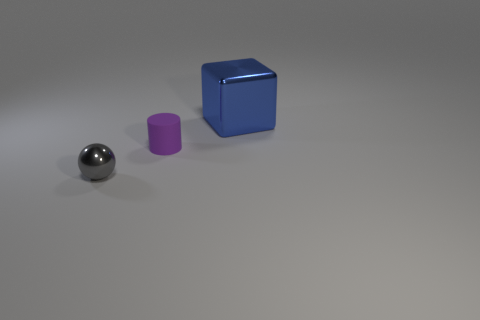Add 3 large metal blocks. How many objects exist? 6 Subtract all cubes. How many objects are left? 2 Add 1 gray metal objects. How many gray metal objects are left? 2 Add 3 yellow cubes. How many yellow cubes exist? 3 Subtract 0 red cylinders. How many objects are left? 3 Subtract all purple matte cylinders. Subtract all small purple rubber things. How many objects are left? 1 